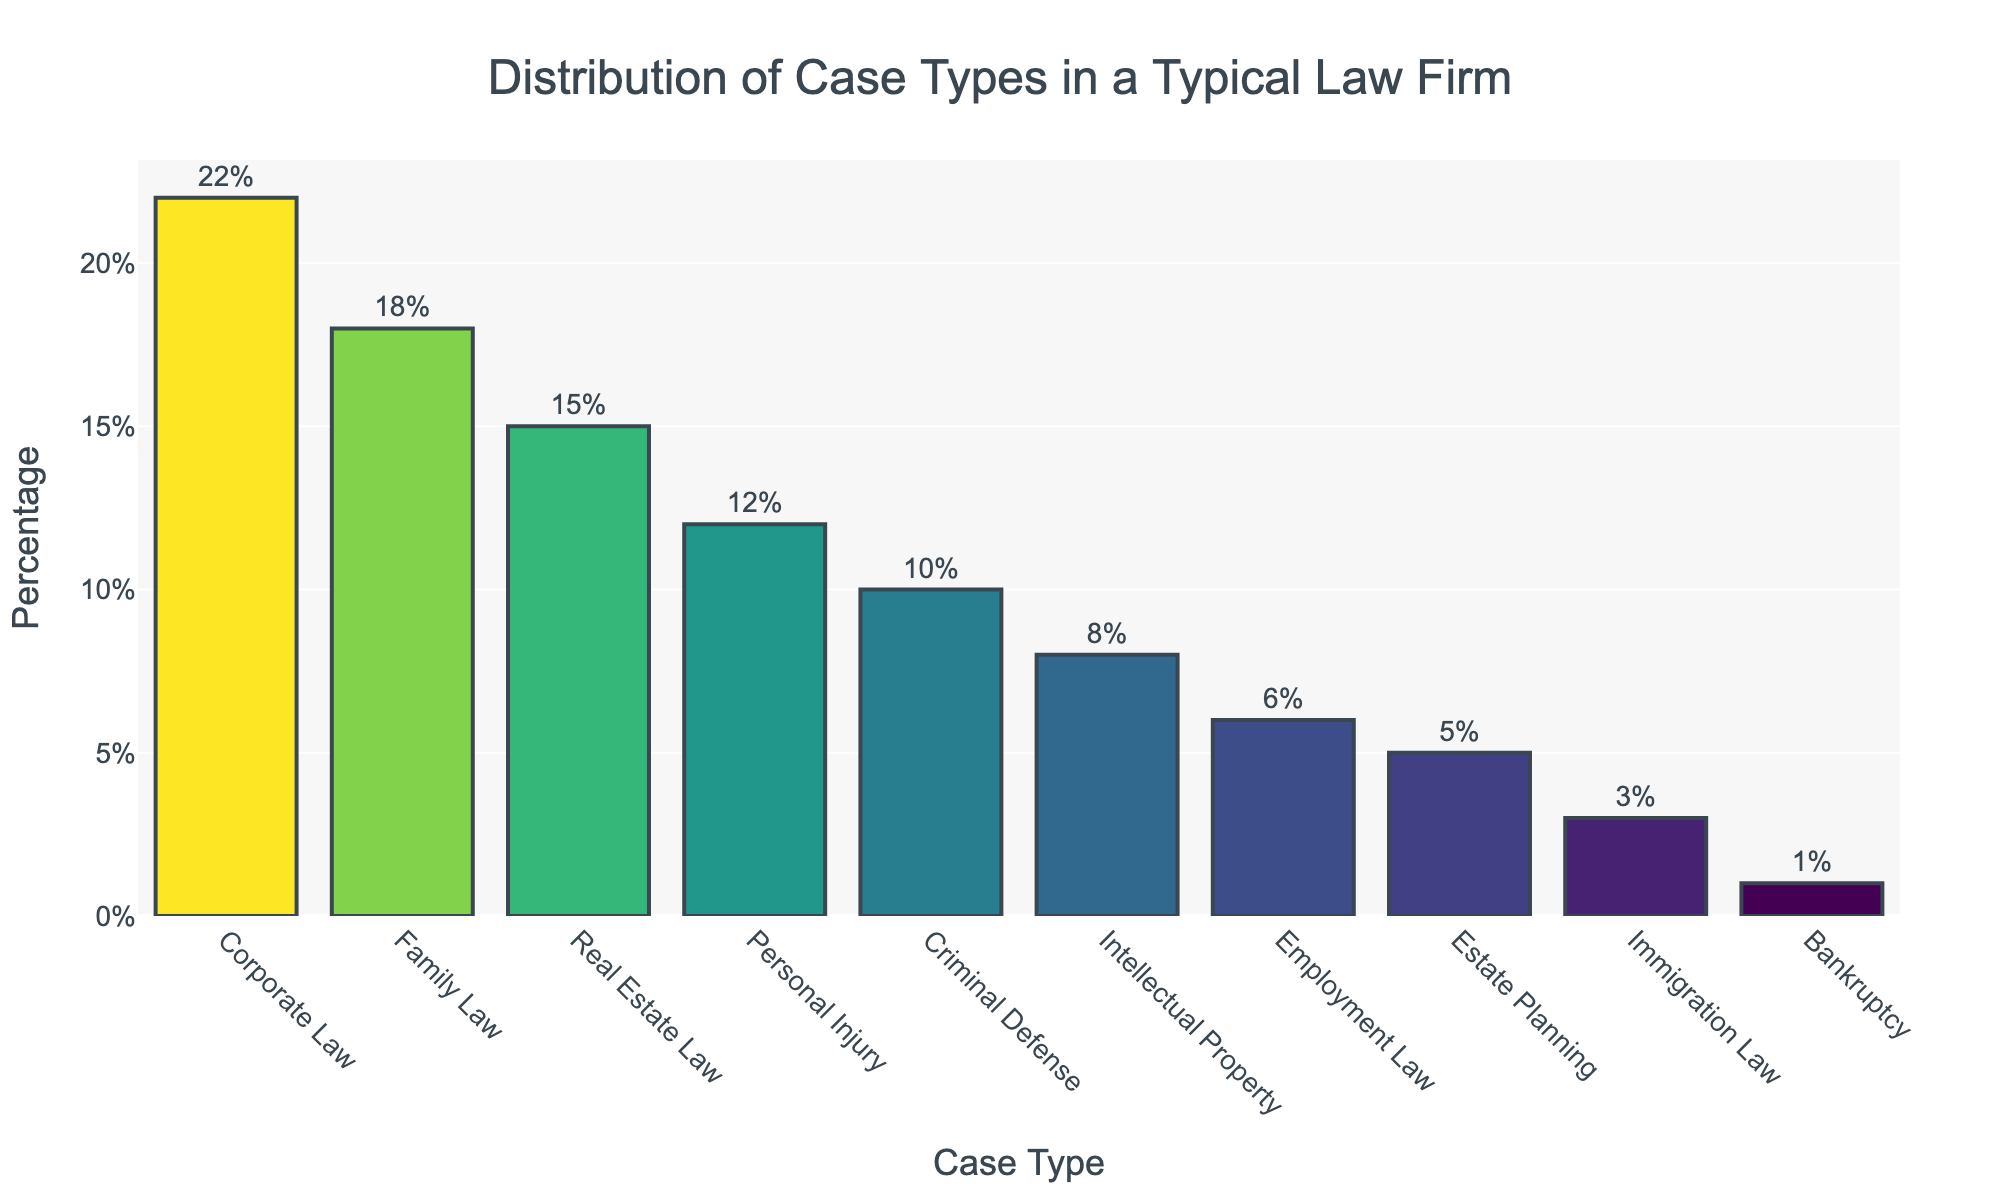which case type has the highest percentage? Look at the tallest bar in the chart which represents the case type with the highest percentage. This bar is labeled “Corporate Law” and has a text label of 22% above it.
Answer: Corporate Law compare the percentages of Corporate Law and Family Law cases Corporate Law is represented with a bar labeled 22% and Family Law with a bar labeled 18%. 22% is higher than 18%, showing that Corporate Law cases are handled more frequently than Family Law cases.
Answer: Corporate Law has a higher percentage what’s the percentage difference between the highest and the lowest case types? Corporate Law, with a percentage of 22%, is the highest. Bankruptcy, with 1%, is the lowest. Subtract the lowest percentage from the highest: 22% - 1% = 21%.
Answer: 21% which three case types are the least common? Look at the shortest bars in the chart. These bars correspond to Bankruptcy, Immigration Law, and Estate Planning, with percentages of 1%, 3%, and 5% respectively.
Answer: Bankruptcy, Immigration Law, Estate Planning what is the total percentage of the top three case types? The top three case types are Corporate Law (22%), Family Law (18%), and Real Estate Law (15%). Add their percentages: 22% + 18% + 15% = 55%.
Answer: 55% is the sum of Personal Injury and Criminal Defense cases greater than the sum of Intellectual Property and Employment Law cases? Calculate the sum for each pair of case types. Personal Injury and Criminal Defense sum to 12% + 10% = 22%. Intellectual Property and Employment Law sum to 8% + 6% = 14%. 22% is greater than 14%.
Answer: Yes which case type appears in the middle in terms of percentage? Order the case types by percentages in ascending order: Bankruptcy, Immigration Law, Estate Planning, Employment Law, Intellectual Property, Criminal Defense, Personal Injury, Real Estate Law, Family Law, Corporate Law. With 10 case types, the middle ones are Employment Law and Intellectual Property.
Answer: Intellectual Property how does the color of the bar for Real Estate Law compare to Employment Law? Real Estate Law has a bar color representing a higher percentage (15%) with a darker green tone compared to the lighter green tone for Employment Law (6%).
Answer: Darker what percentage of cases handled fall under Employment Law, Estate Planning, or Immigration Law? Add the percentages for Employment Law (6%), Estate Planning (5%), and Immigration Law (3%): 6% + 5% + 3% = 14%.
Answer: 14% what approximate percentage do Family Law and Personal Injury cases collectively constitute? Add the percentages for Family Law (18%) and Personal Injury (12%): 18% + 12% = 30%.
Answer: 30% 